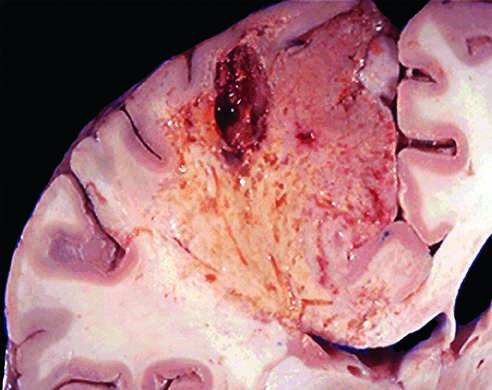does preserved show dissolution of the tissue?
Answer the question using a single word or phrase. No 